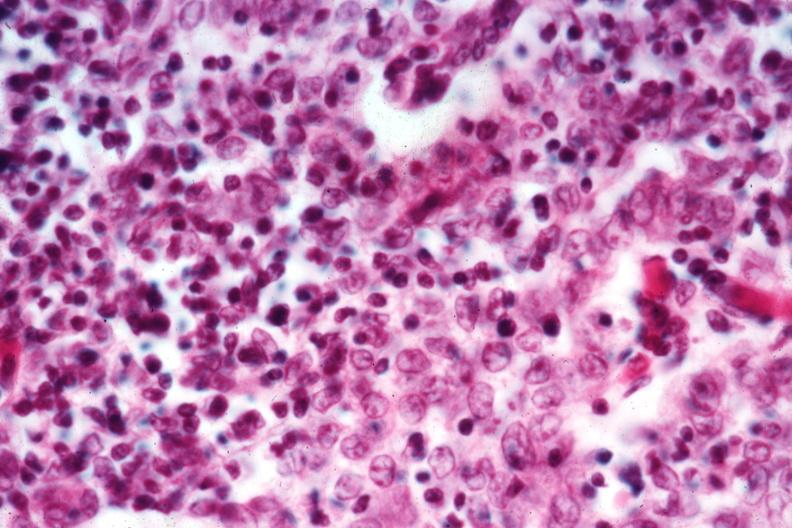what is present?
Answer the question using a single word or phrase. Thymoma 